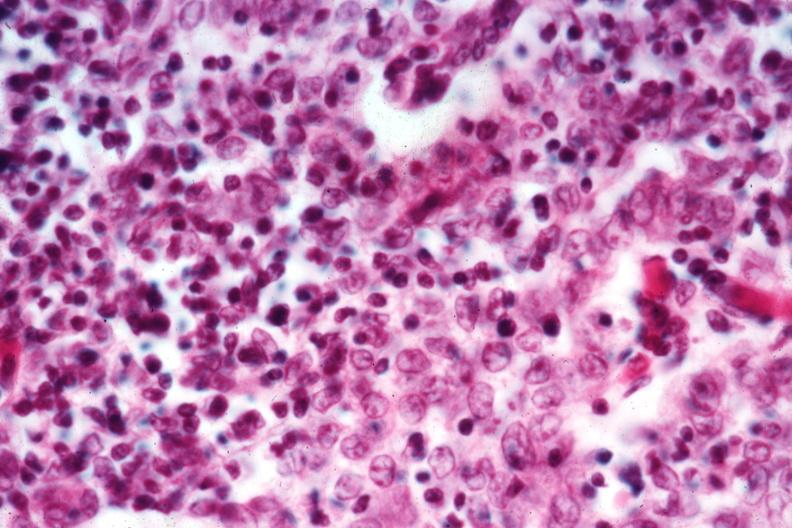what is present?
Answer the question using a single word or phrase. Thymoma 